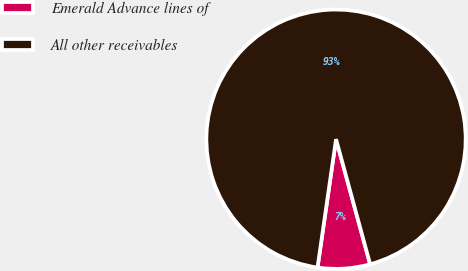Convert chart to OTSL. <chart><loc_0><loc_0><loc_500><loc_500><pie_chart><fcel>Emerald Advance lines of<fcel>All other receivables<nl><fcel>6.52%<fcel>93.48%<nl></chart> 